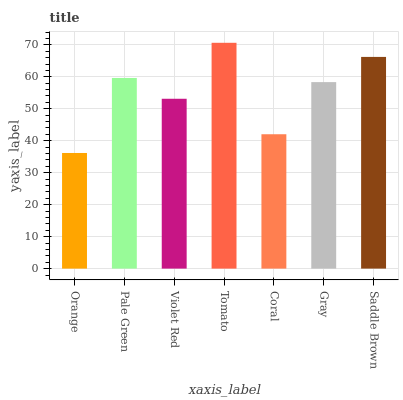Is Orange the minimum?
Answer yes or no. Yes. Is Tomato the maximum?
Answer yes or no. Yes. Is Pale Green the minimum?
Answer yes or no. No. Is Pale Green the maximum?
Answer yes or no. No. Is Pale Green greater than Orange?
Answer yes or no. Yes. Is Orange less than Pale Green?
Answer yes or no. Yes. Is Orange greater than Pale Green?
Answer yes or no. No. Is Pale Green less than Orange?
Answer yes or no. No. Is Gray the high median?
Answer yes or no. Yes. Is Gray the low median?
Answer yes or no. Yes. Is Saddle Brown the high median?
Answer yes or no. No. Is Tomato the low median?
Answer yes or no. No. 